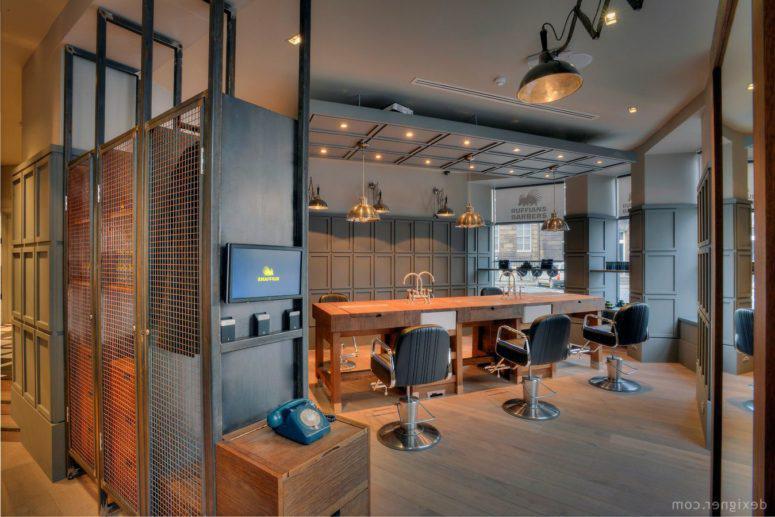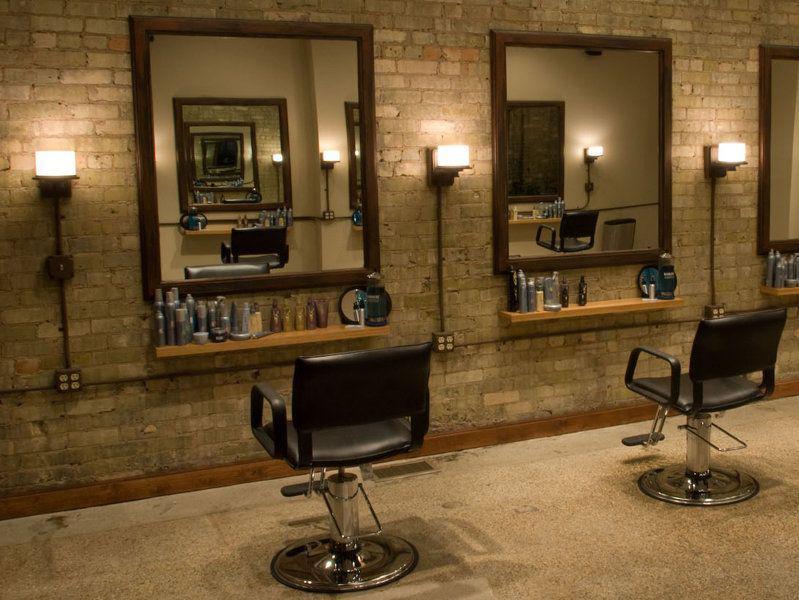The first image is the image on the left, the second image is the image on the right. Considering the images on both sides, is "In at least one image there are three square mirrors." valid? Answer yes or no. Yes. The first image is the image on the left, the second image is the image on the right. For the images displayed, is the sentence "A floor has a checkered pattern." factually correct? Answer yes or no. No. 